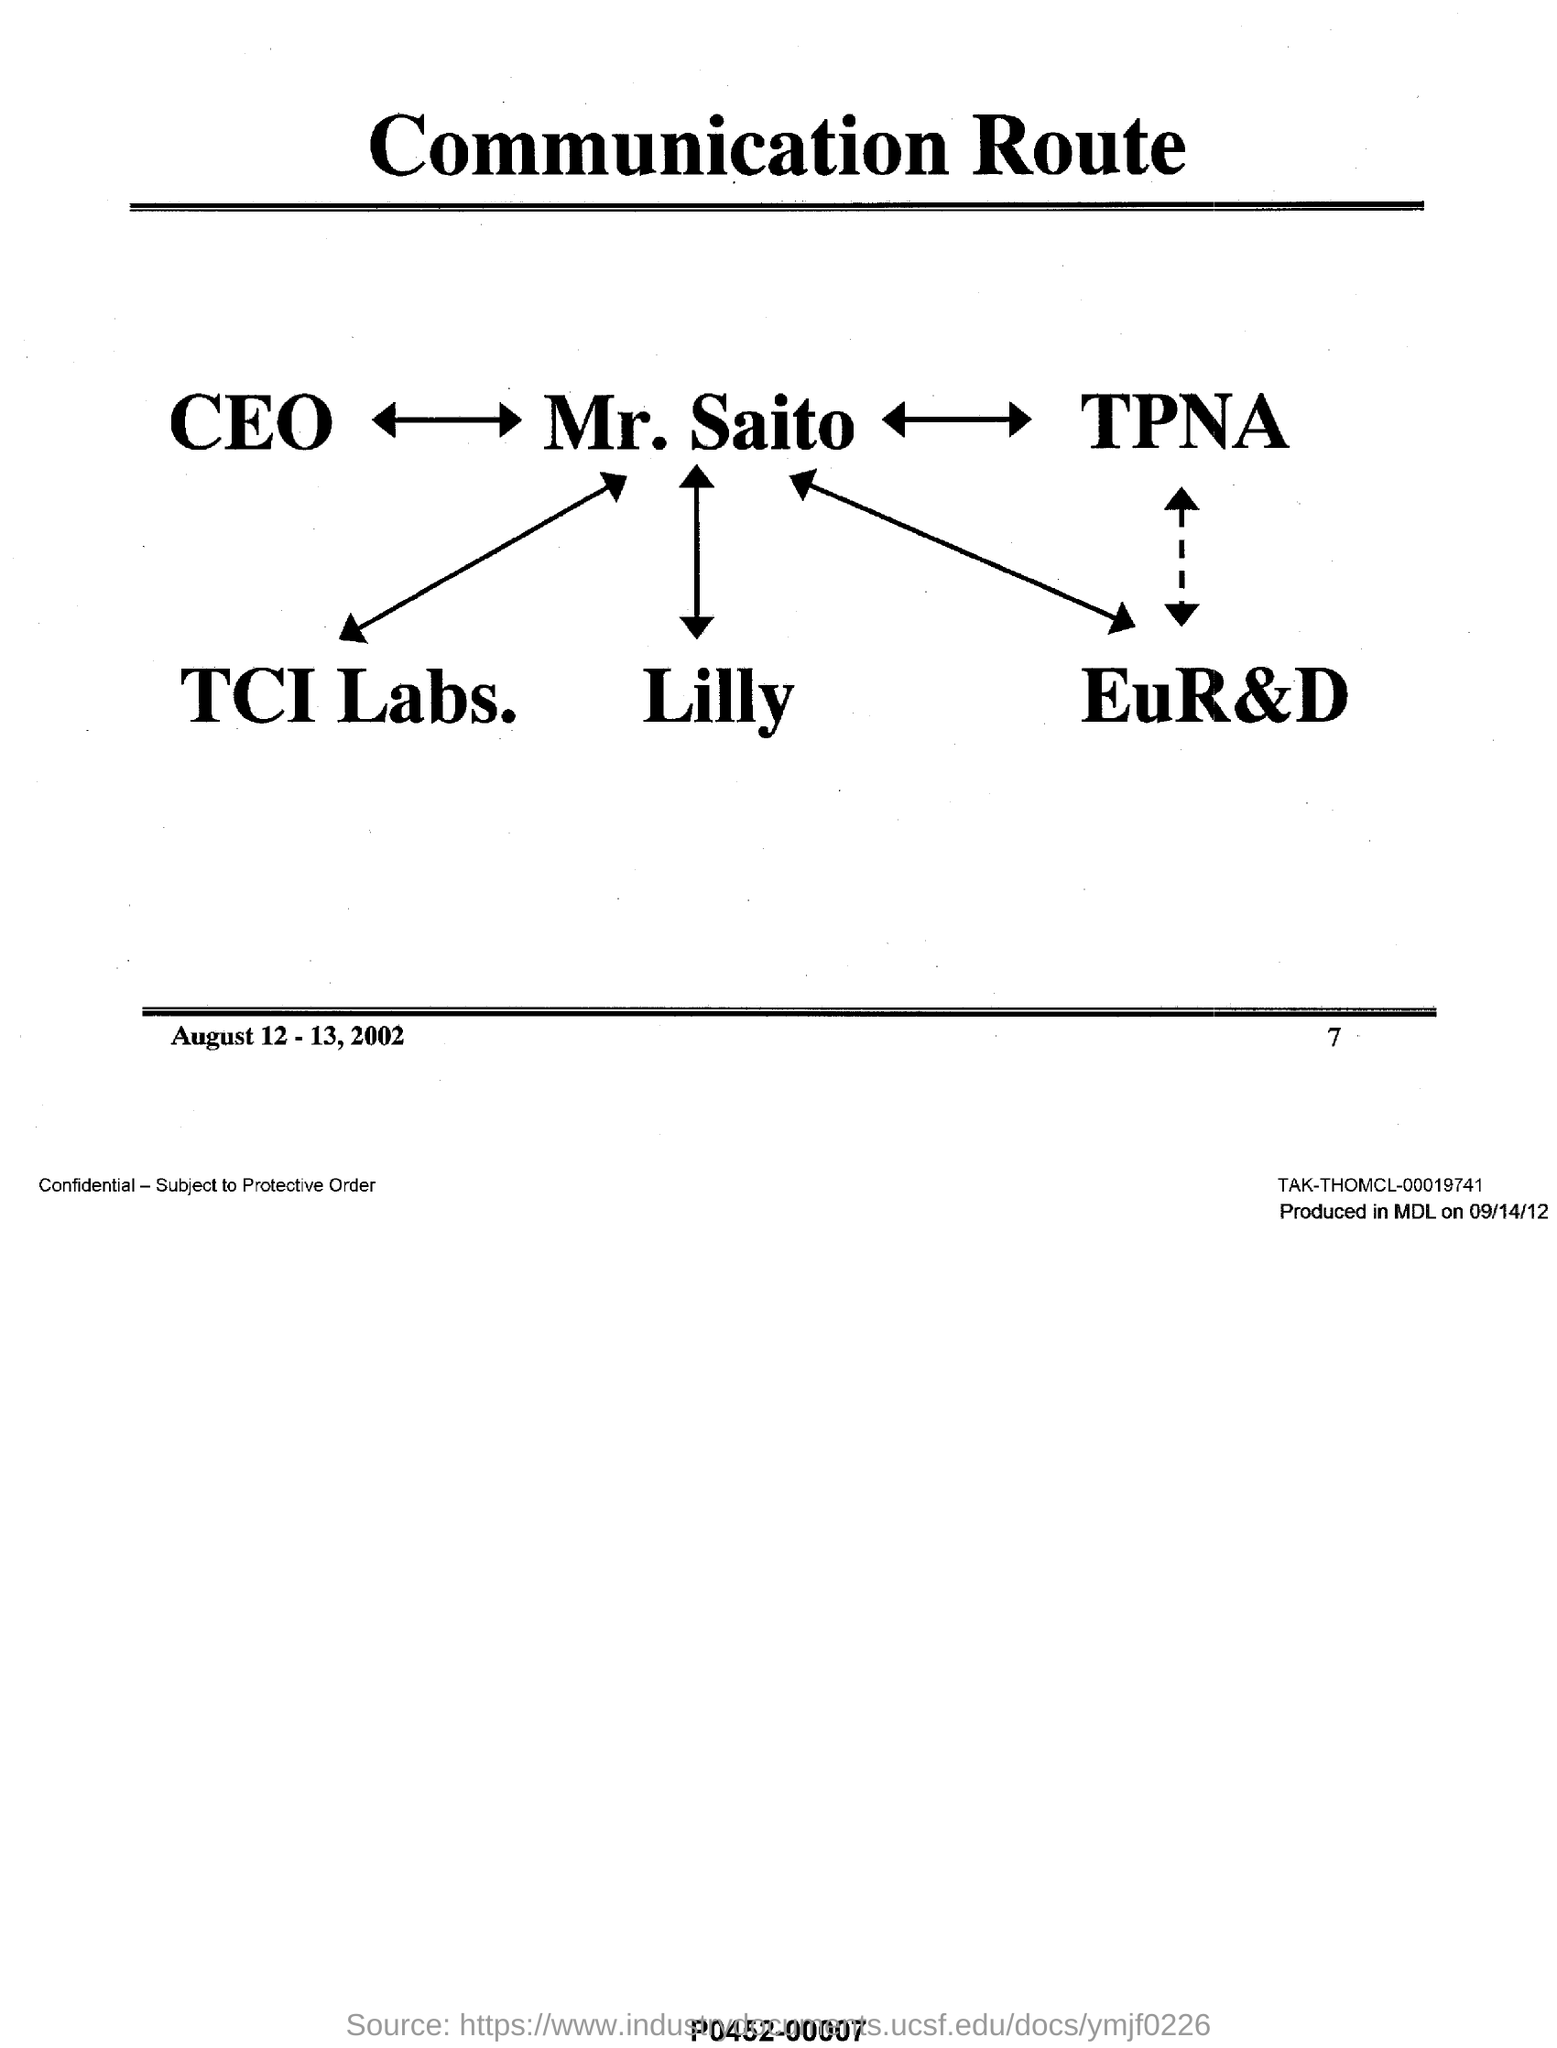What is the date rang  mentioned in this document at the bottom?
Offer a very short reply. August 12 - 13,2002. What is the page no mentioned in this document?
Your response must be concise. 7. What is the title of this document?
Keep it short and to the point. Communication Route. 